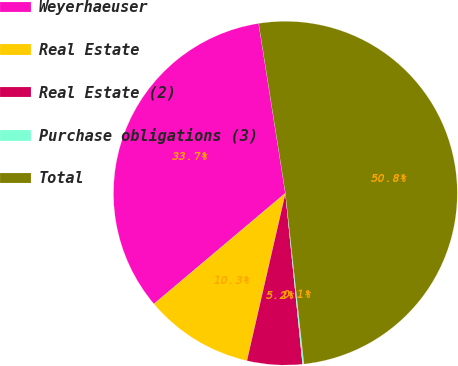Convert chart to OTSL. <chart><loc_0><loc_0><loc_500><loc_500><pie_chart><fcel>Weyerhaeuser<fcel>Real Estate<fcel>Real Estate (2)<fcel>Purchase obligations (3)<fcel>Total<nl><fcel>33.66%<fcel>10.26%<fcel>5.19%<fcel>0.13%<fcel>50.76%<nl></chart> 